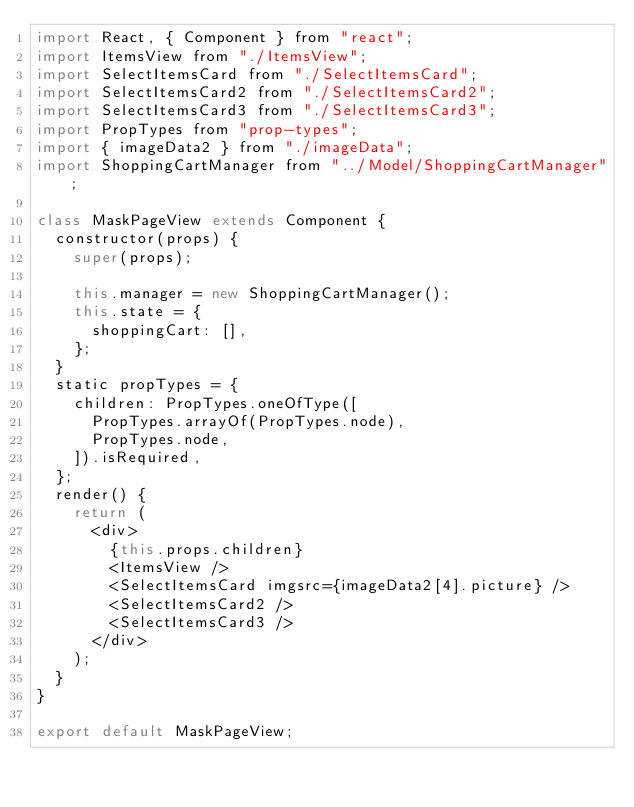<code> <loc_0><loc_0><loc_500><loc_500><_JavaScript_>import React, { Component } from "react";
import ItemsView from "./ItemsView";
import SelectItemsCard from "./SelectItemsCard";
import SelectItemsCard2 from "./SelectItemsCard2";
import SelectItemsCard3 from "./SelectItemsCard3";
import PropTypes from "prop-types";
import { imageData2 } from "./imageData";
import ShoppingCartManager from "../Model/ShoppingCartManager";

class MaskPageView extends Component {
  constructor(props) {
    super(props);

    this.manager = new ShoppingCartManager();
    this.state = {
      shoppingCart: [],
    };
  }
  static propTypes = {
    children: PropTypes.oneOfType([
      PropTypes.arrayOf(PropTypes.node),
      PropTypes.node,
    ]).isRequired,
  };
  render() {
    return (
      <div>
        {this.props.children}
        <ItemsView />
        <SelectItemsCard imgsrc={imageData2[4].picture} />
        <SelectItemsCard2 />
        <SelectItemsCard3 />
      </div>
    );
  }
}

export default MaskPageView;
</code> 